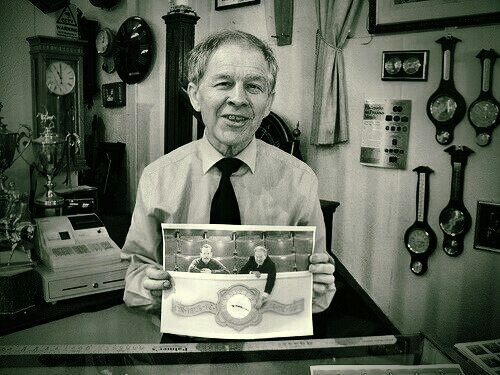Describe the objects in this image and their specific colors. I can see people in black, darkgray, gray, and lightgray tones, clock in black, gray, darkgreen, and darkgray tones, clock in black, gray, and darkgray tones, clock in black, gray, darkgreen, and darkgray tones, and clock in black, gray, darkgray, and darkgreen tones in this image. 